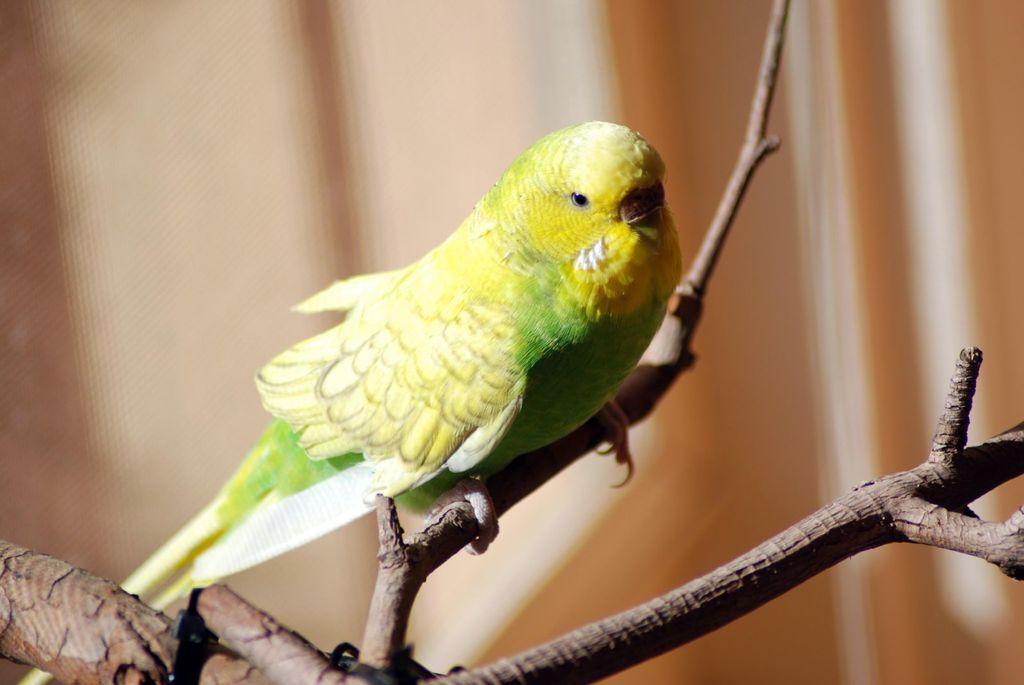Please provide a concise description of this image. In this image, we can see a bird on the stick. In the background, image is blurred. 